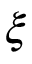<formula> <loc_0><loc_0><loc_500><loc_500>\xi</formula> 